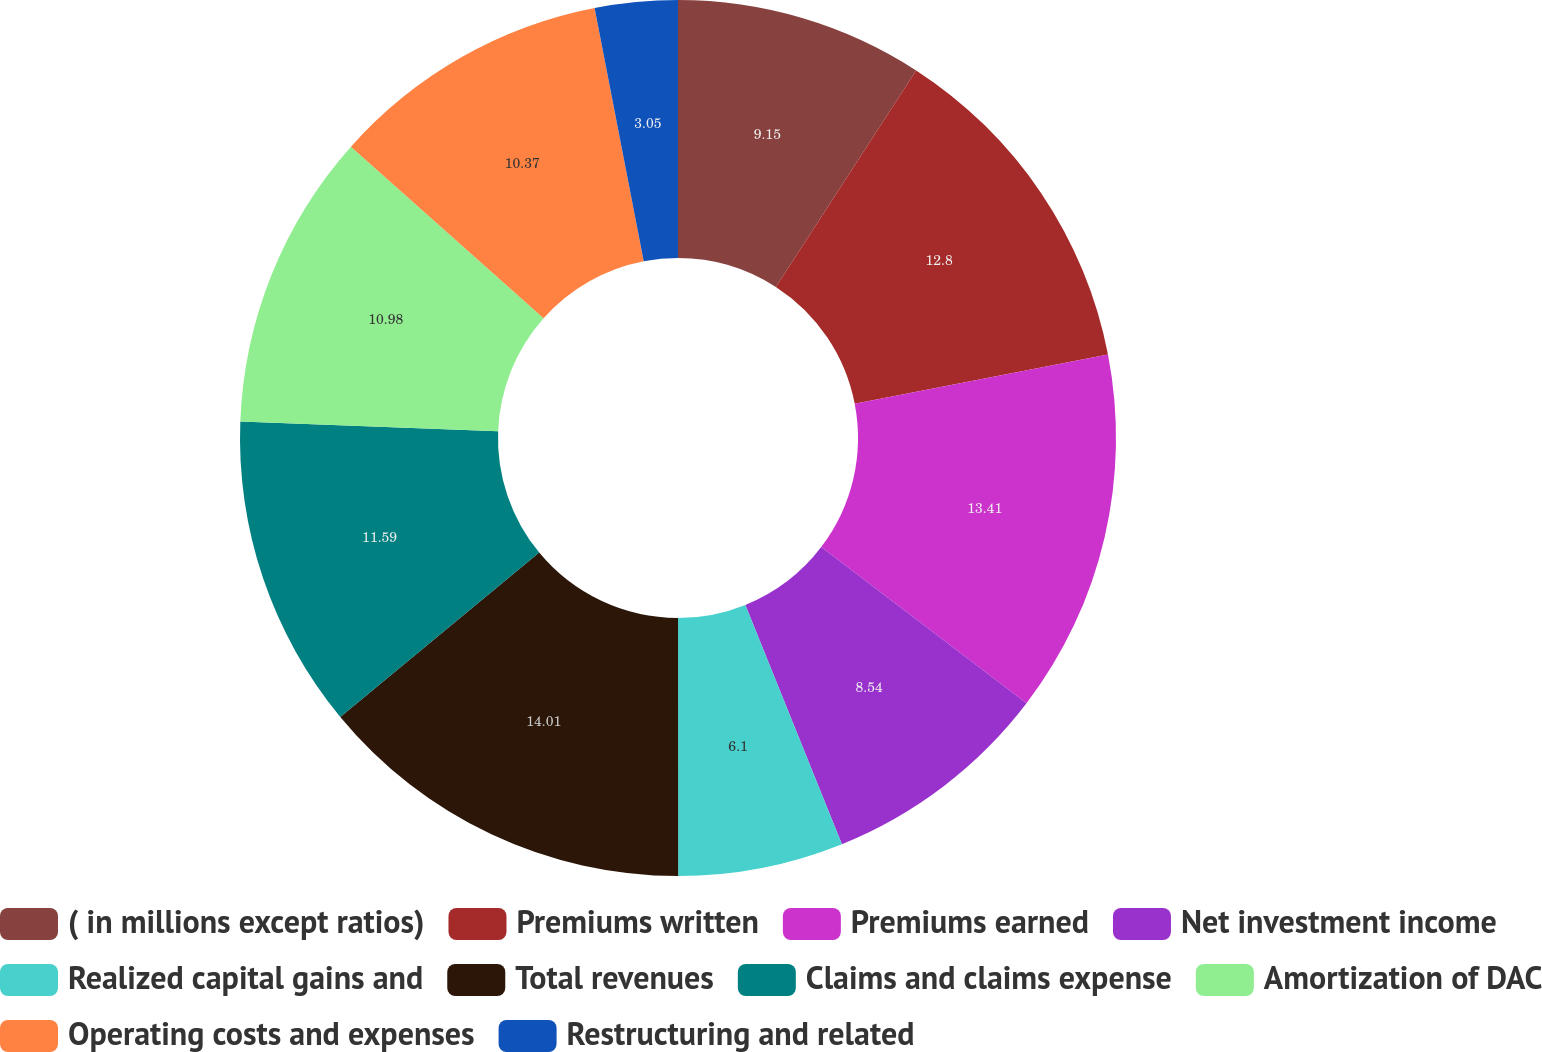Convert chart. <chart><loc_0><loc_0><loc_500><loc_500><pie_chart><fcel>( in millions except ratios)<fcel>Premiums written<fcel>Premiums earned<fcel>Net investment income<fcel>Realized capital gains and<fcel>Total revenues<fcel>Claims and claims expense<fcel>Amortization of DAC<fcel>Operating costs and expenses<fcel>Restructuring and related<nl><fcel>9.15%<fcel>12.8%<fcel>13.41%<fcel>8.54%<fcel>6.1%<fcel>14.02%<fcel>11.59%<fcel>10.98%<fcel>10.37%<fcel>3.05%<nl></chart> 